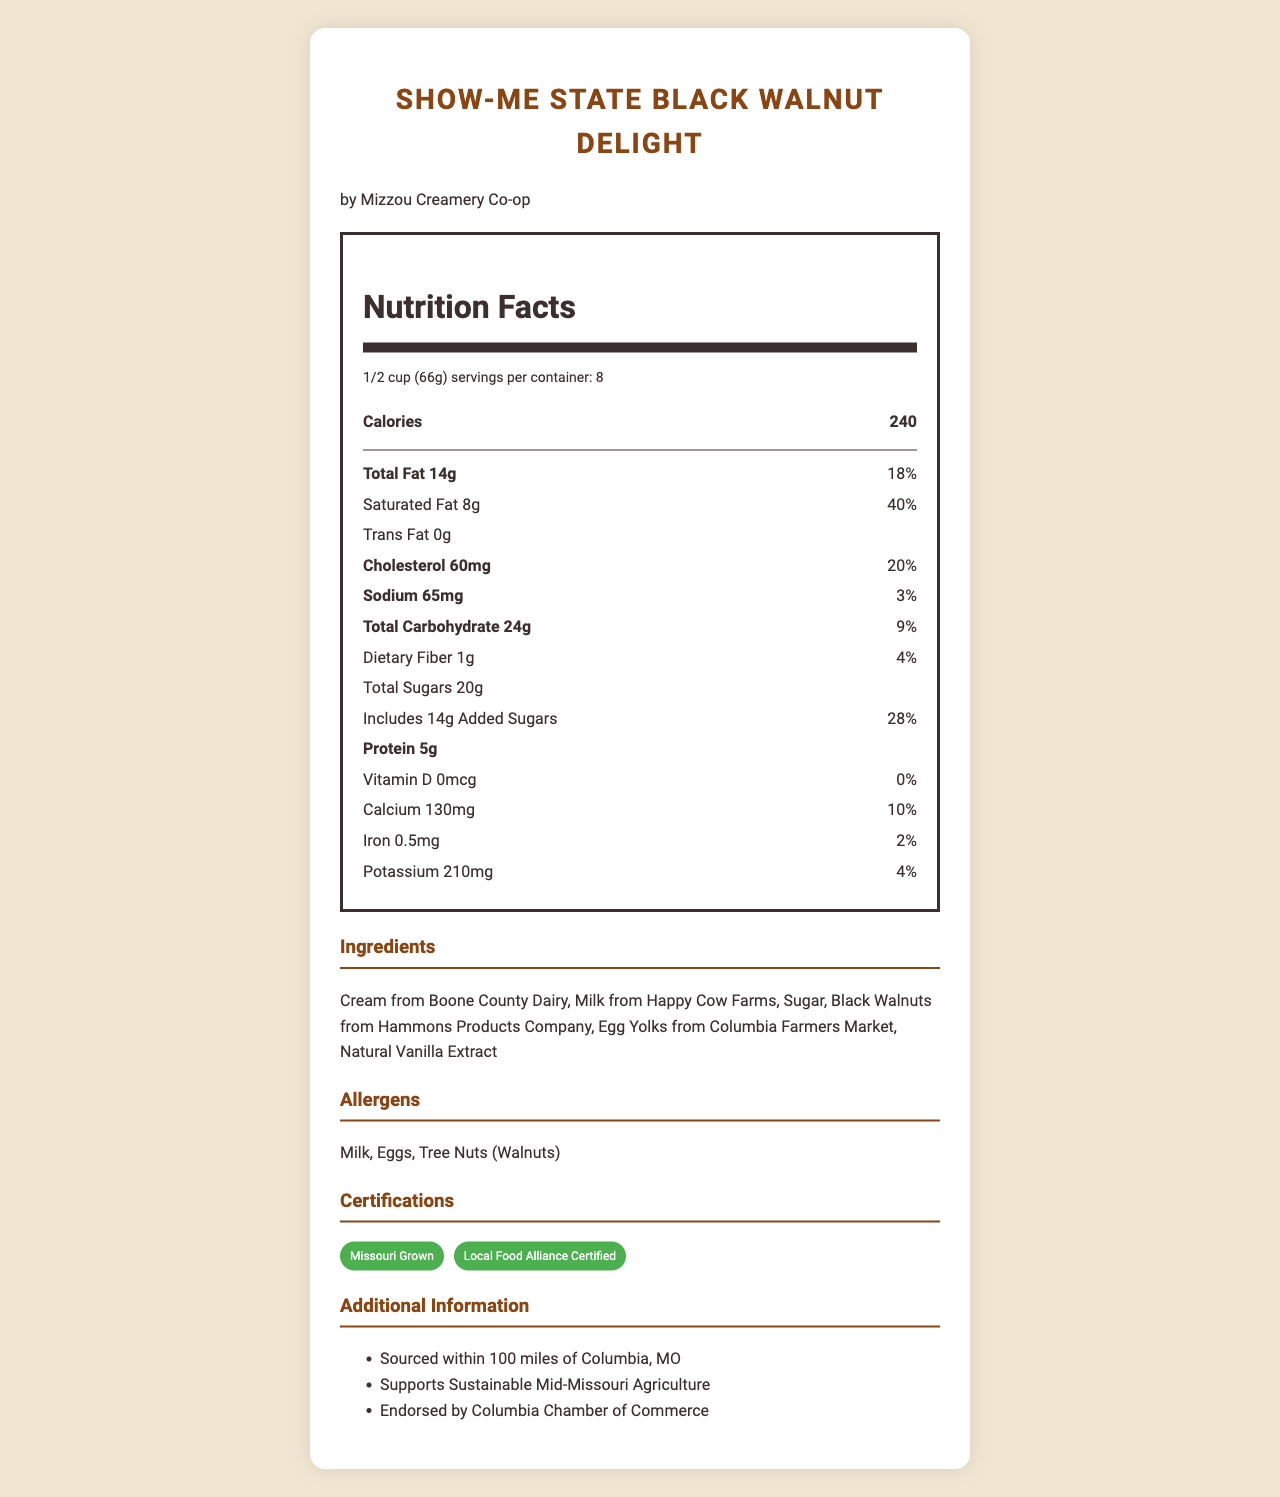what is the serving size of the Show-Me State Black Walnut Delight? The serving size is specified as 1/2 cup (66g) on the document.
Answer: 1/2 cup (66g) who is the manufacturer of the Show-Me State Black Walnut Delight? The manufacturer listed on the document is Mizzou Creamery Co-op.
Answer: Mizzou Creamery Co-op how many calories are in one serving of the ice cream? The document states that one serving of the ice cream contains 240 calories.
Answer: 240 what is the total fat content per serving? The total fat content per serving is 14g as mentioned in the document.
Answer: 14g how much dietary fiber is in one serving? The document lists 1g of dietary fiber per serving.
Answer: 1g what percentage of the daily value for saturated fat does the ice cream contain per serving? The saturated fat content is 8g per serving, which amounts to 40% of the daily value.
Answer: 40% which of the following ingredients are used in this ice cream? A. Palm Oil B. Cream from Boone County Dairy C. Skim Milk D. Caramel Sauce The ingredients listed in the document include "Cream from Boone County Dairy," not the other options.
Answer: B what certifications does the Show-Me State Black Walnut Delight have? A. Organic Certified B. Missouri Grown C. Non-GMO D. Local Food Alliance Certified The document lists "Missouri Grown" and "Local Food Alliance Certified" among its certifications.
Answer: B and D is the ice cream endorsed by the Columbia Chamber of Commerce? The document mentions that the ice cream is endorsed by the Columbia Chamber of Commerce.
Answer: Yes summarize the main nutritional facts and features of the Show-Me State Black Walnut Delight. The document provides detailed nutritional information and highlights the local sourcing and sustainability endorsements of the product.
Answer: The ice cream has 240 calories per serving, with 14g of total fat (including 8g of saturated fat), 24g of carbohydrates (including 20g of total sugars), and 5g of protein. It contains locally-sourced ingredients like cream from Boone County Dairy and black walnuts from Hammons Products Company. It is certified Missouri Grown and Local Food Alliance Certified, and supports sustainable Mid-Missouri agriculture. where is Happy Cow Farms located? The document only mentions that the milk is from Happy Cow Farms, but does not provide the location of the farm.
Answer: Not enough information 